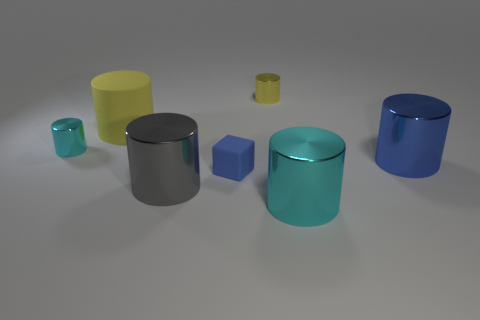What is the large thing that is behind the tiny blue matte cube and on the right side of the small yellow shiny cylinder made of?
Your answer should be compact. Metal. How big is the gray metal object?
Your answer should be compact. Large. There is another small object that is the same shape as the small cyan thing; what color is it?
Give a very brief answer. Yellow. Is there any other thing that is the same color as the large matte thing?
Your answer should be compact. Yes. There is a cyan shiny cylinder in front of the large gray cylinder; is it the same size as the cyan cylinder that is left of the large yellow thing?
Provide a succinct answer. No. Is the number of blue things to the right of the blue matte cube the same as the number of blue objects behind the large blue object?
Keep it short and to the point. No. There is a yellow matte cylinder; is its size the same as the cyan object in front of the blue shiny thing?
Your answer should be very brief. Yes. Are there any small rubber cubes that are left of the small metal thing left of the tiny rubber cube?
Keep it short and to the point. No. Are there any large brown matte objects that have the same shape as the small yellow thing?
Provide a succinct answer. No. There is a cylinder right of the cyan shiny object that is right of the tiny yellow thing; what number of small cylinders are right of it?
Make the answer very short. 0. 